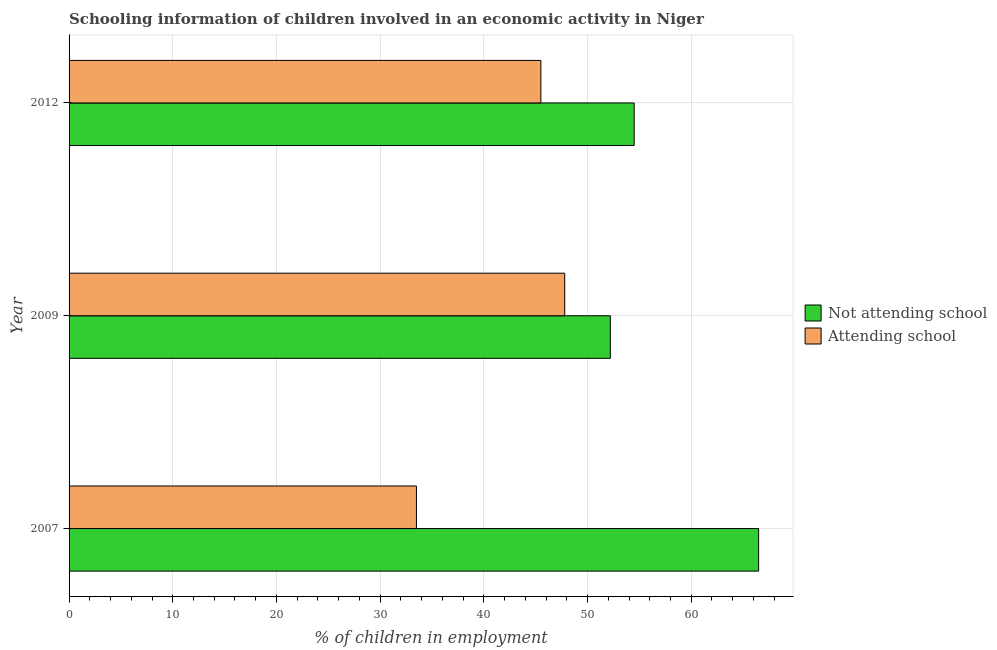How many different coloured bars are there?
Offer a terse response. 2. How many groups of bars are there?
Make the answer very short. 3. What is the percentage of employed children who are not attending school in 2012?
Offer a terse response. 54.5. Across all years, what is the maximum percentage of employed children who are attending school?
Provide a succinct answer. 47.8. Across all years, what is the minimum percentage of employed children who are attending school?
Give a very brief answer. 33.5. In which year was the percentage of employed children who are attending school maximum?
Your answer should be very brief. 2009. What is the total percentage of employed children who are not attending school in the graph?
Keep it short and to the point. 173.2. What is the difference between the percentage of employed children who are attending school in 2012 and the percentage of employed children who are not attending school in 2007?
Offer a terse response. -21. What is the average percentage of employed children who are not attending school per year?
Your answer should be very brief. 57.73. In the year 2007, what is the difference between the percentage of employed children who are attending school and percentage of employed children who are not attending school?
Make the answer very short. -33. In how many years, is the percentage of employed children who are attending school greater than 42 %?
Keep it short and to the point. 2. What is the ratio of the percentage of employed children who are not attending school in 2007 to that in 2009?
Your answer should be very brief. 1.27. What is the difference between the highest and the lowest percentage of employed children who are not attending school?
Offer a very short reply. 14.3. In how many years, is the percentage of employed children who are attending school greater than the average percentage of employed children who are attending school taken over all years?
Your answer should be compact. 2. What does the 1st bar from the top in 2007 represents?
Provide a succinct answer. Attending school. What does the 2nd bar from the bottom in 2007 represents?
Offer a terse response. Attending school. How many bars are there?
Your response must be concise. 6. Are all the bars in the graph horizontal?
Keep it short and to the point. Yes. How many years are there in the graph?
Provide a succinct answer. 3. Does the graph contain any zero values?
Your answer should be compact. No. Where does the legend appear in the graph?
Give a very brief answer. Center right. How are the legend labels stacked?
Provide a short and direct response. Vertical. What is the title of the graph?
Ensure brevity in your answer.  Schooling information of children involved in an economic activity in Niger. Does "Highest 10% of population" appear as one of the legend labels in the graph?
Your answer should be very brief. No. What is the label or title of the X-axis?
Give a very brief answer. % of children in employment. What is the % of children in employment in Not attending school in 2007?
Ensure brevity in your answer.  66.5. What is the % of children in employment of Attending school in 2007?
Make the answer very short. 33.5. What is the % of children in employment in Not attending school in 2009?
Your answer should be very brief. 52.2. What is the % of children in employment in Attending school in 2009?
Offer a terse response. 47.8. What is the % of children in employment of Not attending school in 2012?
Your answer should be very brief. 54.5. What is the % of children in employment of Attending school in 2012?
Your answer should be compact. 45.5. Across all years, what is the maximum % of children in employment in Not attending school?
Provide a succinct answer. 66.5. Across all years, what is the maximum % of children in employment of Attending school?
Offer a very short reply. 47.8. Across all years, what is the minimum % of children in employment of Not attending school?
Ensure brevity in your answer.  52.2. Across all years, what is the minimum % of children in employment in Attending school?
Provide a succinct answer. 33.5. What is the total % of children in employment of Not attending school in the graph?
Provide a succinct answer. 173.2. What is the total % of children in employment of Attending school in the graph?
Make the answer very short. 126.8. What is the difference between the % of children in employment in Not attending school in 2007 and that in 2009?
Provide a short and direct response. 14.3. What is the difference between the % of children in employment of Attending school in 2007 and that in 2009?
Your response must be concise. -14.3. What is the difference between the % of children in employment of Not attending school in 2007 and that in 2012?
Offer a terse response. 12. What is the difference between the % of children in employment in Not attending school in 2009 and that in 2012?
Give a very brief answer. -2.3. What is the difference between the % of children in employment in Not attending school in 2007 and the % of children in employment in Attending school in 2009?
Provide a succinct answer. 18.7. What is the difference between the % of children in employment in Not attending school in 2007 and the % of children in employment in Attending school in 2012?
Provide a succinct answer. 21. What is the average % of children in employment in Not attending school per year?
Your response must be concise. 57.73. What is the average % of children in employment of Attending school per year?
Give a very brief answer. 42.27. In the year 2012, what is the difference between the % of children in employment in Not attending school and % of children in employment in Attending school?
Keep it short and to the point. 9. What is the ratio of the % of children in employment in Not attending school in 2007 to that in 2009?
Your answer should be very brief. 1.27. What is the ratio of the % of children in employment in Attending school in 2007 to that in 2009?
Give a very brief answer. 0.7. What is the ratio of the % of children in employment of Not attending school in 2007 to that in 2012?
Offer a terse response. 1.22. What is the ratio of the % of children in employment of Attending school in 2007 to that in 2012?
Provide a short and direct response. 0.74. What is the ratio of the % of children in employment of Not attending school in 2009 to that in 2012?
Your response must be concise. 0.96. What is the ratio of the % of children in employment of Attending school in 2009 to that in 2012?
Make the answer very short. 1.05. What is the difference between the highest and the second highest % of children in employment of Attending school?
Your answer should be compact. 2.3. What is the difference between the highest and the lowest % of children in employment of Not attending school?
Provide a short and direct response. 14.3. 